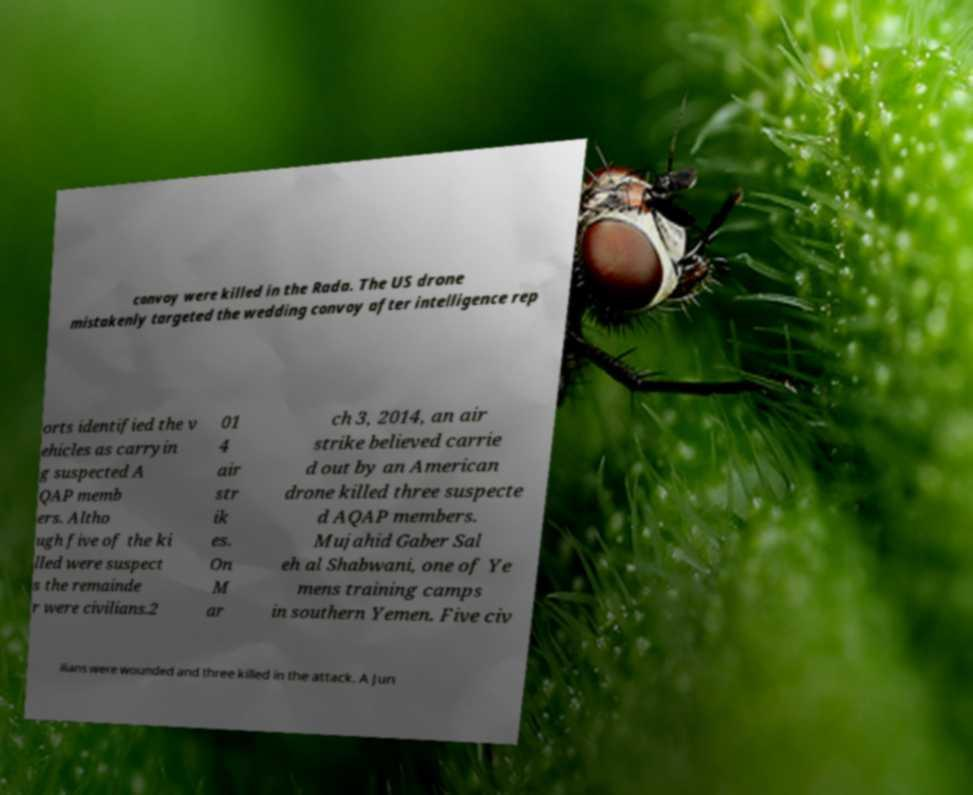Could you extract and type out the text from this image? convoy were killed in the Rada. The US drone mistakenly targeted the wedding convoy after intelligence rep orts identified the v ehicles as carryin g suspected A QAP memb ers. Altho ugh five of the ki lled were suspect s the remainde r were civilians.2 01 4 air str ik es. On M ar ch 3, 2014, an air strike believed carrie d out by an American drone killed three suspecte d AQAP members. Mujahid Gaber Sal eh al Shabwani, one of Ye mens training camps in southern Yemen. Five civ ilians were wounded and three killed in the attack. A Jun 